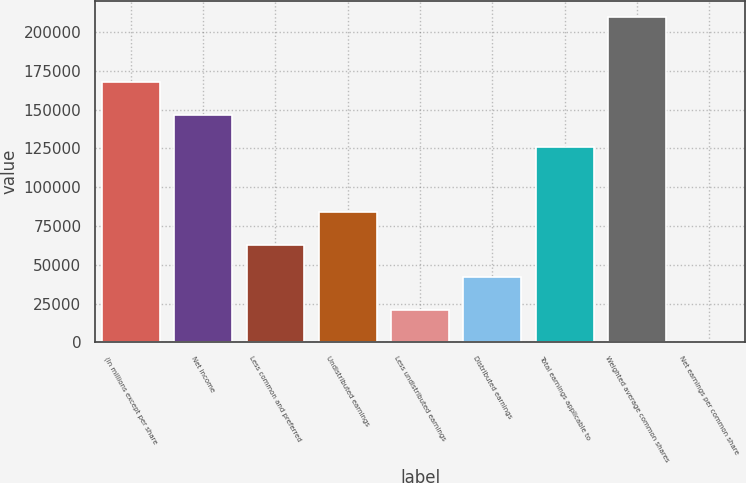<chart> <loc_0><loc_0><loc_500><loc_500><bar_chart><fcel>(In millions except per share<fcel>Net income<fcel>Less common and preferred<fcel>Undistributed earnings<fcel>Less undistributed earnings<fcel>Distributed earnings<fcel>Total earnings applicable to<fcel>Weighted average common shares<fcel>Net earnings per common share<nl><fcel>167723<fcel>146758<fcel>62897.8<fcel>83862.8<fcel>20967.7<fcel>41932.8<fcel>125793<fcel>209653<fcel>2.71<nl></chart> 